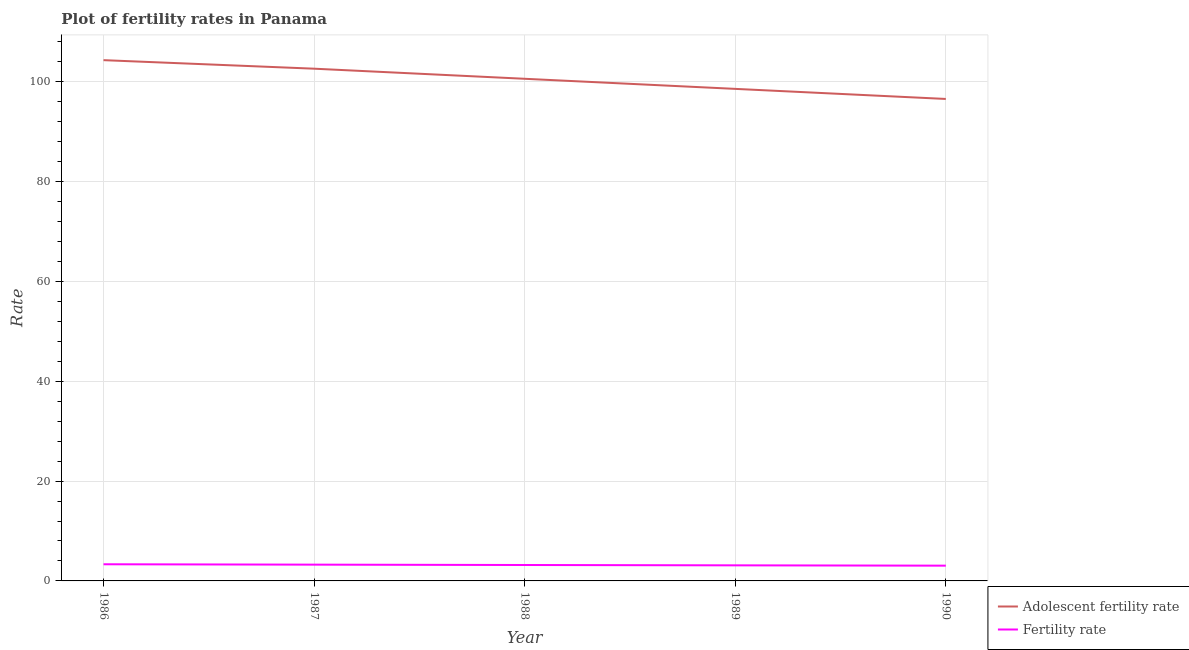Does the line corresponding to fertility rate intersect with the line corresponding to adolescent fertility rate?
Make the answer very short. No. Is the number of lines equal to the number of legend labels?
Provide a succinct answer. Yes. What is the fertility rate in 1986?
Your answer should be very brief. 3.34. Across all years, what is the maximum adolescent fertility rate?
Offer a very short reply. 104.29. Across all years, what is the minimum fertility rate?
Provide a short and direct response. 3.06. In which year was the adolescent fertility rate maximum?
Ensure brevity in your answer.  1986. What is the total fertility rate in the graph?
Your response must be concise. 15.97. What is the difference between the adolescent fertility rate in 1987 and that in 1989?
Provide a succinct answer. 4.04. What is the difference between the adolescent fertility rate in 1990 and the fertility rate in 1986?
Give a very brief answer. 93.19. What is the average fertility rate per year?
Ensure brevity in your answer.  3.19. In the year 1988, what is the difference between the adolescent fertility rate and fertility rate?
Give a very brief answer. 97.37. In how many years, is the fertility rate greater than 72?
Offer a terse response. 0. What is the ratio of the fertility rate in 1986 to that in 1987?
Keep it short and to the point. 1.02. Is the difference between the adolescent fertility rate in 1988 and 1990 greater than the difference between the fertility rate in 1988 and 1990?
Offer a terse response. Yes. What is the difference between the highest and the second highest adolescent fertility rate?
Your answer should be compact. 1.71. What is the difference between the highest and the lowest fertility rate?
Your answer should be compact. 0.28. Is the sum of the adolescent fertility rate in 1986 and 1987 greater than the maximum fertility rate across all years?
Your answer should be very brief. Yes. Are the values on the major ticks of Y-axis written in scientific E-notation?
Your response must be concise. No. What is the title of the graph?
Provide a short and direct response. Plot of fertility rates in Panama. Does "Goods" appear as one of the legend labels in the graph?
Your answer should be compact. No. What is the label or title of the X-axis?
Your answer should be very brief. Year. What is the label or title of the Y-axis?
Your answer should be very brief. Rate. What is the Rate in Adolescent fertility rate in 1986?
Your response must be concise. 104.29. What is the Rate in Fertility rate in 1986?
Ensure brevity in your answer.  3.34. What is the Rate of Adolescent fertility rate in 1987?
Keep it short and to the point. 102.58. What is the Rate of Fertility rate in 1987?
Offer a terse response. 3.26. What is the Rate of Adolescent fertility rate in 1988?
Your answer should be very brief. 100.56. What is the Rate in Fertility rate in 1988?
Provide a short and direct response. 3.19. What is the Rate of Adolescent fertility rate in 1989?
Give a very brief answer. 98.54. What is the Rate of Fertility rate in 1989?
Provide a short and direct response. 3.12. What is the Rate in Adolescent fertility rate in 1990?
Your answer should be compact. 96.52. What is the Rate in Fertility rate in 1990?
Make the answer very short. 3.06. Across all years, what is the maximum Rate of Adolescent fertility rate?
Give a very brief answer. 104.29. Across all years, what is the maximum Rate of Fertility rate?
Offer a terse response. 3.34. Across all years, what is the minimum Rate of Adolescent fertility rate?
Give a very brief answer. 96.52. Across all years, what is the minimum Rate in Fertility rate?
Offer a terse response. 3.06. What is the total Rate in Adolescent fertility rate in the graph?
Keep it short and to the point. 502.51. What is the total Rate in Fertility rate in the graph?
Your answer should be very brief. 15.97. What is the difference between the Rate of Adolescent fertility rate in 1986 and that in 1987?
Your answer should be compact. 1.71. What is the difference between the Rate of Fertility rate in 1986 and that in 1987?
Ensure brevity in your answer.  0.07. What is the difference between the Rate of Adolescent fertility rate in 1986 and that in 1988?
Offer a very short reply. 3.73. What is the difference between the Rate in Fertility rate in 1986 and that in 1988?
Offer a terse response. 0.15. What is the difference between the Rate in Adolescent fertility rate in 1986 and that in 1989?
Ensure brevity in your answer.  5.75. What is the difference between the Rate in Fertility rate in 1986 and that in 1989?
Offer a very short reply. 0.21. What is the difference between the Rate in Adolescent fertility rate in 1986 and that in 1990?
Your answer should be compact. 7.77. What is the difference between the Rate of Fertility rate in 1986 and that in 1990?
Keep it short and to the point. 0.28. What is the difference between the Rate of Adolescent fertility rate in 1987 and that in 1988?
Offer a very short reply. 2.02. What is the difference between the Rate in Fertility rate in 1987 and that in 1988?
Provide a succinct answer. 0.07. What is the difference between the Rate of Adolescent fertility rate in 1987 and that in 1989?
Ensure brevity in your answer.  4.04. What is the difference between the Rate in Fertility rate in 1987 and that in 1989?
Offer a very short reply. 0.14. What is the difference between the Rate in Adolescent fertility rate in 1987 and that in 1990?
Make the answer very short. 6.06. What is the difference between the Rate of Fertility rate in 1987 and that in 1990?
Provide a succinct answer. 0.2. What is the difference between the Rate in Adolescent fertility rate in 1988 and that in 1989?
Provide a succinct answer. 2.02. What is the difference between the Rate of Fertility rate in 1988 and that in 1989?
Offer a very short reply. 0.07. What is the difference between the Rate of Adolescent fertility rate in 1988 and that in 1990?
Provide a short and direct response. 4.04. What is the difference between the Rate in Fertility rate in 1988 and that in 1990?
Provide a short and direct response. 0.13. What is the difference between the Rate in Adolescent fertility rate in 1989 and that in 1990?
Your answer should be very brief. 2.02. What is the difference between the Rate of Fertility rate in 1989 and that in 1990?
Offer a terse response. 0.06. What is the difference between the Rate in Adolescent fertility rate in 1986 and the Rate in Fertility rate in 1987?
Offer a terse response. 101.03. What is the difference between the Rate of Adolescent fertility rate in 1986 and the Rate of Fertility rate in 1988?
Your response must be concise. 101.1. What is the difference between the Rate of Adolescent fertility rate in 1986 and the Rate of Fertility rate in 1989?
Offer a terse response. 101.17. What is the difference between the Rate in Adolescent fertility rate in 1986 and the Rate in Fertility rate in 1990?
Your answer should be very brief. 101.24. What is the difference between the Rate of Adolescent fertility rate in 1987 and the Rate of Fertility rate in 1988?
Ensure brevity in your answer.  99.39. What is the difference between the Rate of Adolescent fertility rate in 1987 and the Rate of Fertility rate in 1989?
Give a very brief answer. 99.46. What is the difference between the Rate in Adolescent fertility rate in 1987 and the Rate in Fertility rate in 1990?
Keep it short and to the point. 99.53. What is the difference between the Rate in Adolescent fertility rate in 1988 and the Rate in Fertility rate in 1989?
Keep it short and to the point. 97.44. What is the difference between the Rate of Adolescent fertility rate in 1988 and the Rate of Fertility rate in 1990?
Offer a very short reply. 97.51. What is the difference between the Rate in Adolescent fertility rate in 1989 and the Rate in Fertility rate in 1990?
Keep it short and to the point. 95.49. What is the average Rate of Adolescent fertility rate per year?
Your answer should be compact. 100.5. What is the average Rate in Fertility rate per year?
Ensure brevity in your answer.  3.19. In the year 1986, what is the difference between the Rate in Adolescent fertility rate and Rate in Fertility rate?
Ensure brevity in your answer.  100.96. In the year 1987, what is the difference between the Rate in Adolescent fertility rate and Rate in Fertility rate?
Make the answer very short. 99.32. In the year 1988, what is the difference between the Rate in Adolescent fertility rate and Rate in Fertility rate?
Your response must be concise. 97.37. In the year 1989, what is the difference between the Rate in Adolescent fertility rate and Rate in Fertility rate?
Keep it short and to the point. 95.42. In the year 1990, what is the difference between the Rate of Adolescent fertility rate and Rate of Fertility rate?
Ensure brevity in your answer.  93.47. What is the ratio of the Rate in Adolescent fertility rate in 1986 to that in 1987?
Your answer should be compact. 1.02. What is the ratio of the Rate in Fertility rate in 1986 to that in 1987?
Provide a succinct answer. 1.02. What is the ratio of the Rate of Adolescent fertility rate in 1986 to that in 1988?
Provide a succinct answer. 1.04. What is the ratio of the Rate in Fertility rate in 1986 to that in 1988?
Offer a terse response. 1.05. What is the ratio of the Rate in Adolescent fertility rate in 1986 to that in 1989?
Offer a terse response. 1.06. What is the ratio of the Rate of Fertility rate in 1986 to that in 1989?
Provide a short and direct response. 1.07. What is the ratio of the Rate in Adolescent fertility rate in 1986 to that in 1990?
Make the answer very short. 1.08. What is the ratio of the Rate in Fertility rate in 1986 to that in 1990?
Make the answer very short. 1.09. What is the ratio of the Rate in Adolescent fertility rate in 1987 to that in 1988?
Keep it short and to the point. 1.02. What is the ratio of the Rate in Fertility rate in 1987 to that in 1988?
Keep it short and to the point. 1.02. What is the ratio of the Rate of Adolescent fertility rate in 1987 to that in 1989?
Make the answer very short. 1.04. What is the ratio of the Rate of Fertility rate in 1987 to that in 1989?
Your answer should be compact. 1.05. What is the ratio of the Rate of Adolescent fertility rate in 1987 to that in 1990?
Keep it short and to the point. 1.06. What is the ratio of the Rate of Fertility rate in 1987 to that in 1990?
Make the answer very short. 1.07. What is the ratio of the Rate of Adolescent fertility rate in 1988 to that in 1989?
Give a very brief answer. 1.02. What is the ratio of the Rate of Fertility rate in 1988 to that in 1989?
Provide a short and direct response. 1.02. What is the ratio of the Rate in Adolescent fertility rate in 1988 to that in 1990?
Offer a terse response. 1.04. What is the ratio of the Rate of Fertility rate in 1988 to that in 1990?
Your answer should be very brief. 1.04. What is the ratio of the Rate of Adolescent fertility rate in 1989 to that in 1990?
Provide a short and direct response. 1.02. What is the ratio of the Rate in Fertility rate in 1989 to that in 1990?
Your answer should be compact. 1.02. What is the difference between the highest and the second highest Rate in Adolescent fertility rate?
Provide a short and direct response. 1.71. What is the difference between the highest and the second highest Rate in Fertility rate?
Your answer should be very brief. 0.07. What is the difference between the highest and the lowest Rate of Adolescent fertility rate?
Ensure brevity in your answer.  7.77. What is the difference between the highest and the lowest Rate of Fertility rate?
Give a very brief answer. 0.28. 